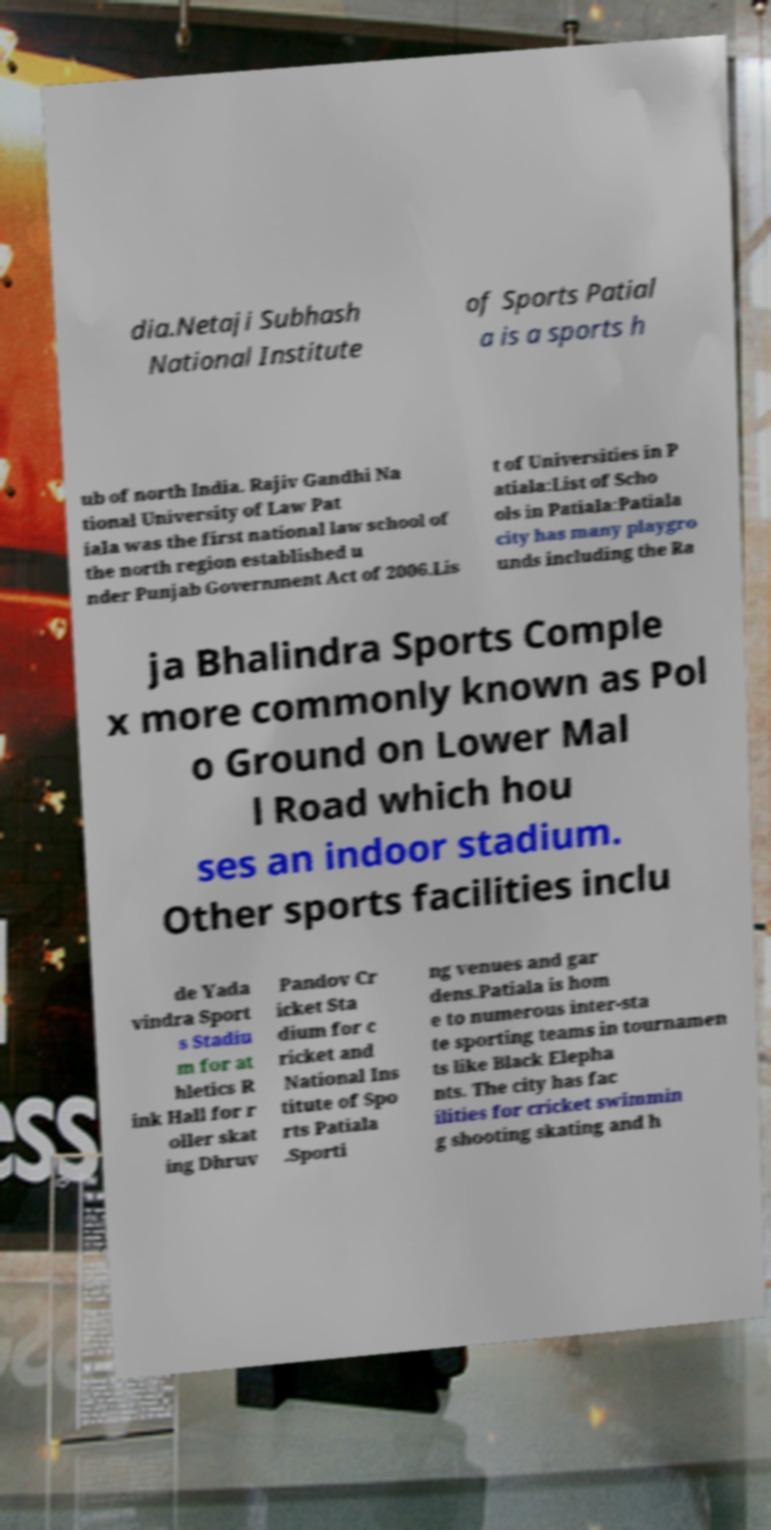Can you accurately transcribe the text from the provided image for me? dia.Netaji Subhash National Institute of Sports Patial a is a sports h ub of north India. Rajiv Gandhi Na tional University of Law Pat iala was the first national law school of the north region established u nder Punjab Government Act of 2006.Lis t of Universities in P atiala:List of Scho ols in Patiala:Patiala city has many playgro unds including the Ra ja Bhalindra Sports Comple x more commonly known as Pol o Ground on Lower Mal l Road which hou ses an indoor stadium. Other sports facilities inclu de Yada vindra Sport s Stadiu m for at hletics R ink Hall for r oller skat ing Dhruv Pandov Cr icket Sta dium for c ricket and National Ins titute of Spo rts Patiala .Sporti ng venues and gar dens.Patiala is hom e to numerous inter-sta te sporting teams in tournamen ts like Black Elepha nts. The city has fac ilities for cricket swimmin g shooting skating and h 